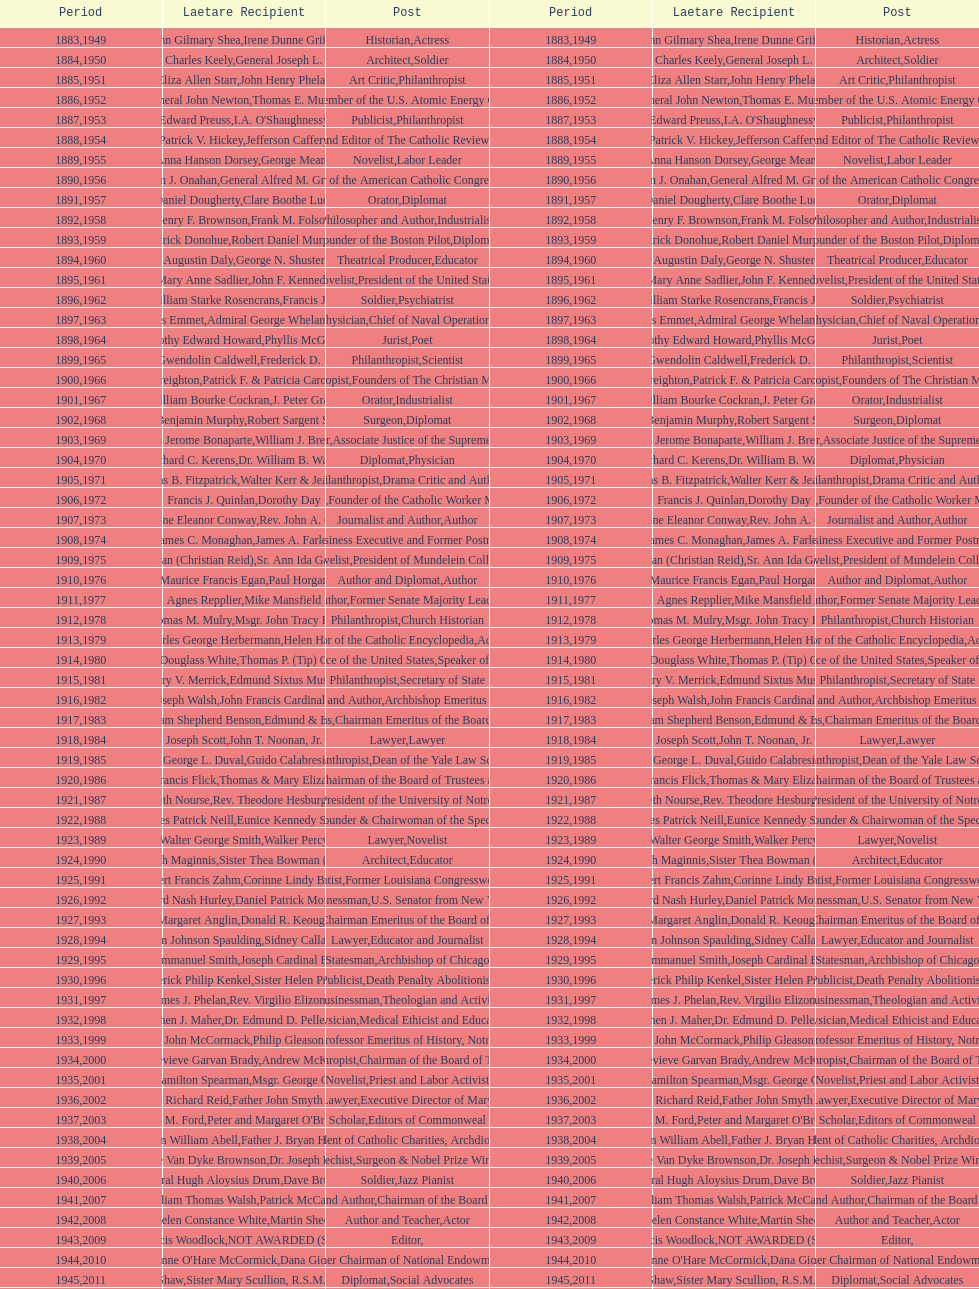How many times does philanthropist appear in the position column on this chart? 9. 